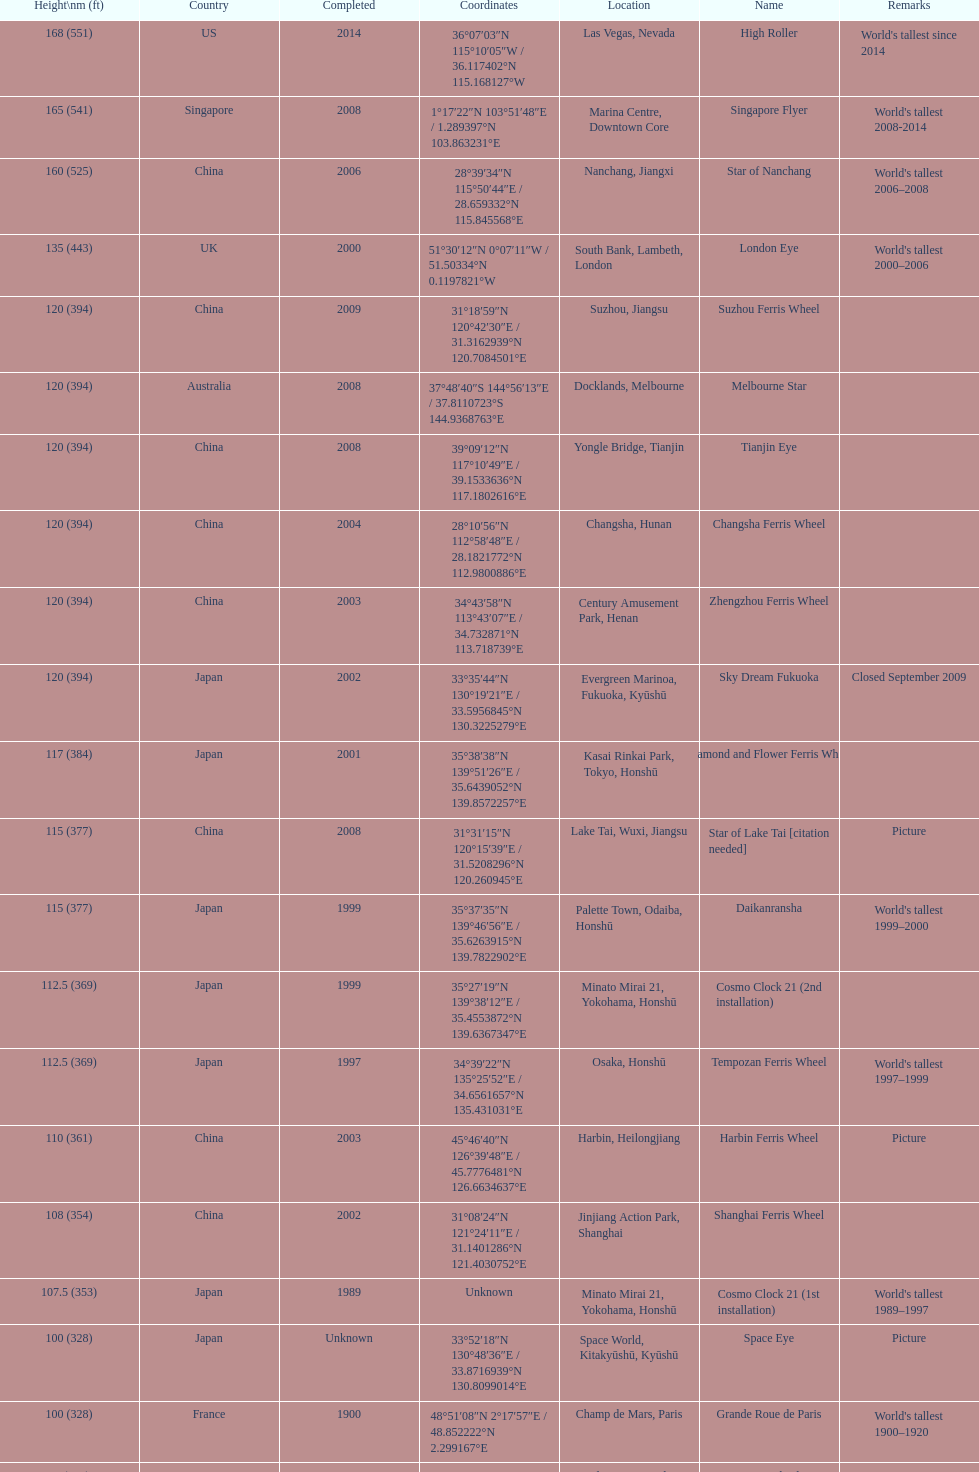Where was the original tallest roller coster built? Chicago. 